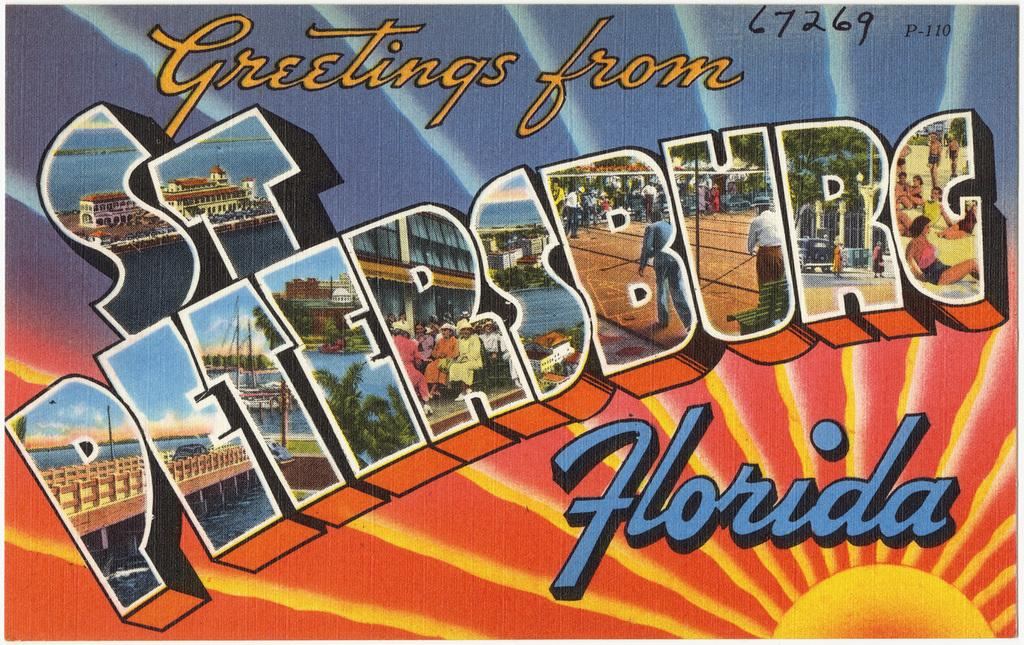What is the main subject of the poster in the image? The poster contains images of trees, water, people, and buildings. Can you describe the images of trees on the poster? The poster contains images of trees. What other types of images are present on the poster? The poster contains images of water and people. Are there any buildings depicted on the poster? Yes, the poster contains images of buildings. Is there any text on the poster? Yes, the poster contains text. Can you describe the volcano erupting in the image? There is no volcano present in the image; the poster contains images of trees, water, people, and buildings. How does the town react to the rainstorm in the image? There is no rainstorm or town depicted in the image; the poster contains images of trees, water, people, and buildings. 